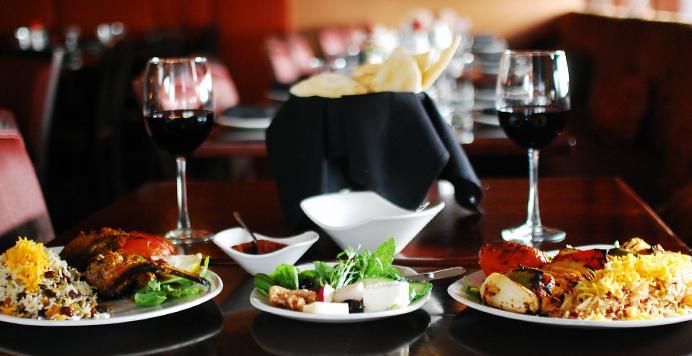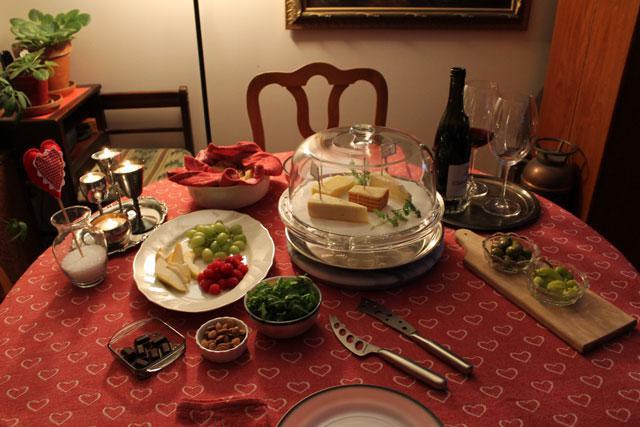The first image is the image on the left, the second image is the image on the right. For the images displayed, is the sentence "Left image shows a table holding exactly two glasses, which contain dark wine." factually correct? Answer yes or no. Yes. The first image is the image on the left, the second image is the image on the right. For the images displayed, is the sentence "The table in the image on the left has a white table cloth." factually correct? Answer yes or no. No. 